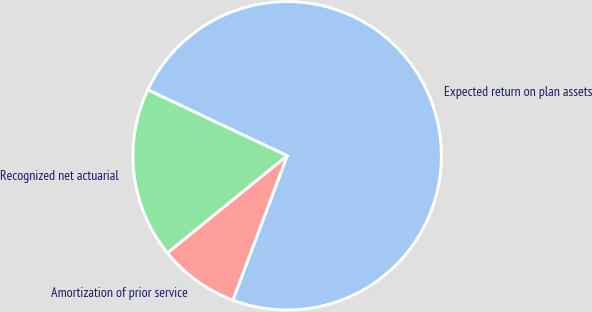Convert chart to OTSL. <chart><loc_0><loc_0><loc_500><loc_500><pie_chart><fcel>Expected return on plan assets<fcel>Recognized net actuarial<fcel>Amortization of prior service<nl><fcel>73.68%<fcel>17.89%<fcel>8.42%<nl></chart> 